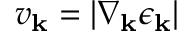Convert formula to latex. <formula><loc_0><loc_0><loc_500><loc_500>v _ { k } = | \nabla _ { k } \epsilon _ { k } |</formula> 